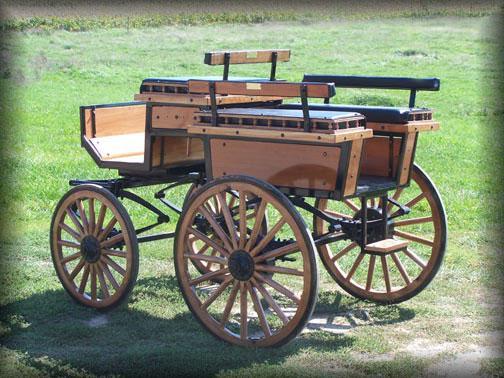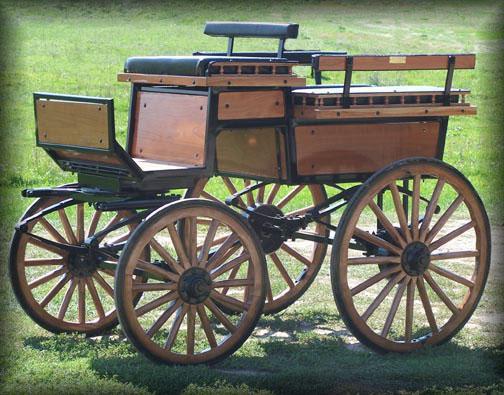The first image is the image on the left, the second image is the image on the right. Assess this claim about the two images: "The wheels in one of the images have metal spokes.". Correct or not? Answer yes or no. No. 